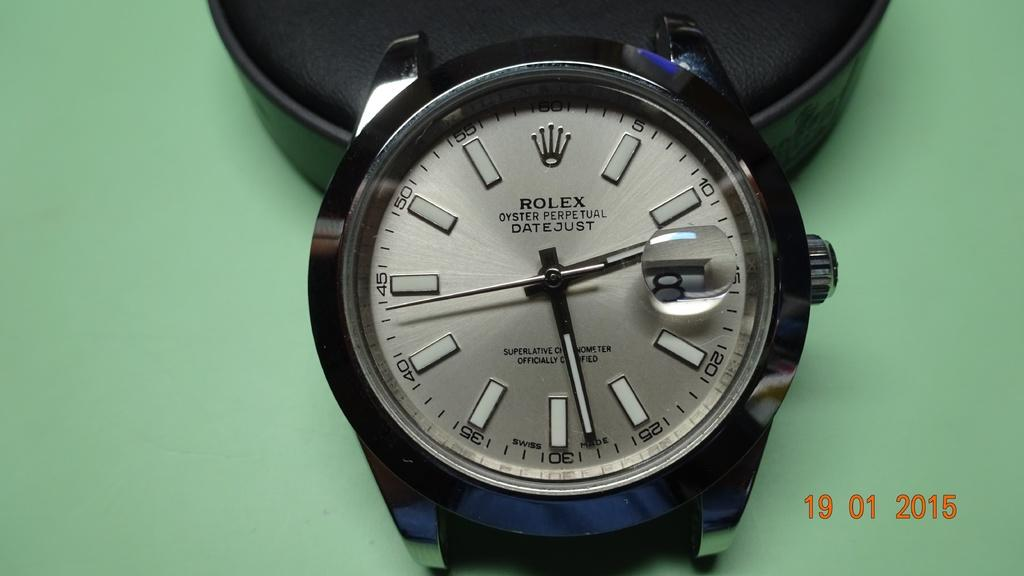Provide a one-sentence caption for the provided image. A very expensive rolex watch that displays seconds as numbers. 